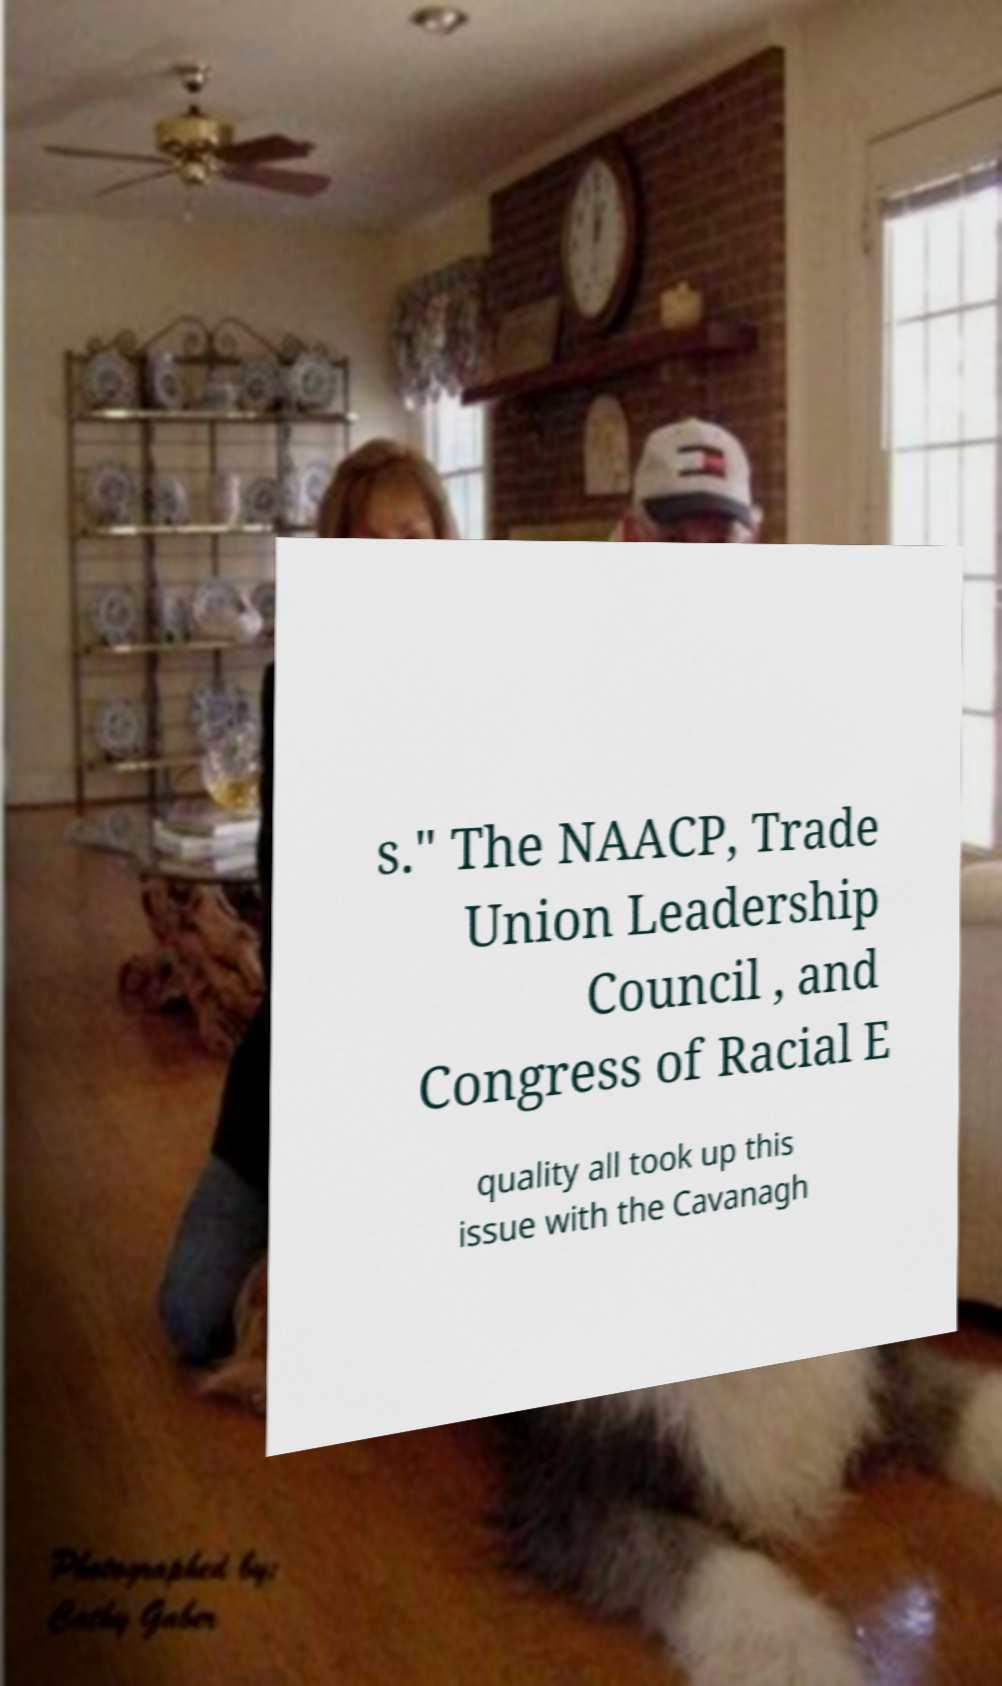Can you accurately transcribe the text from the provided image for me? s." The NAACP, Trade Union Leadership Council , and Congress of Racial E quality all took up this issue with the Cavanagh 